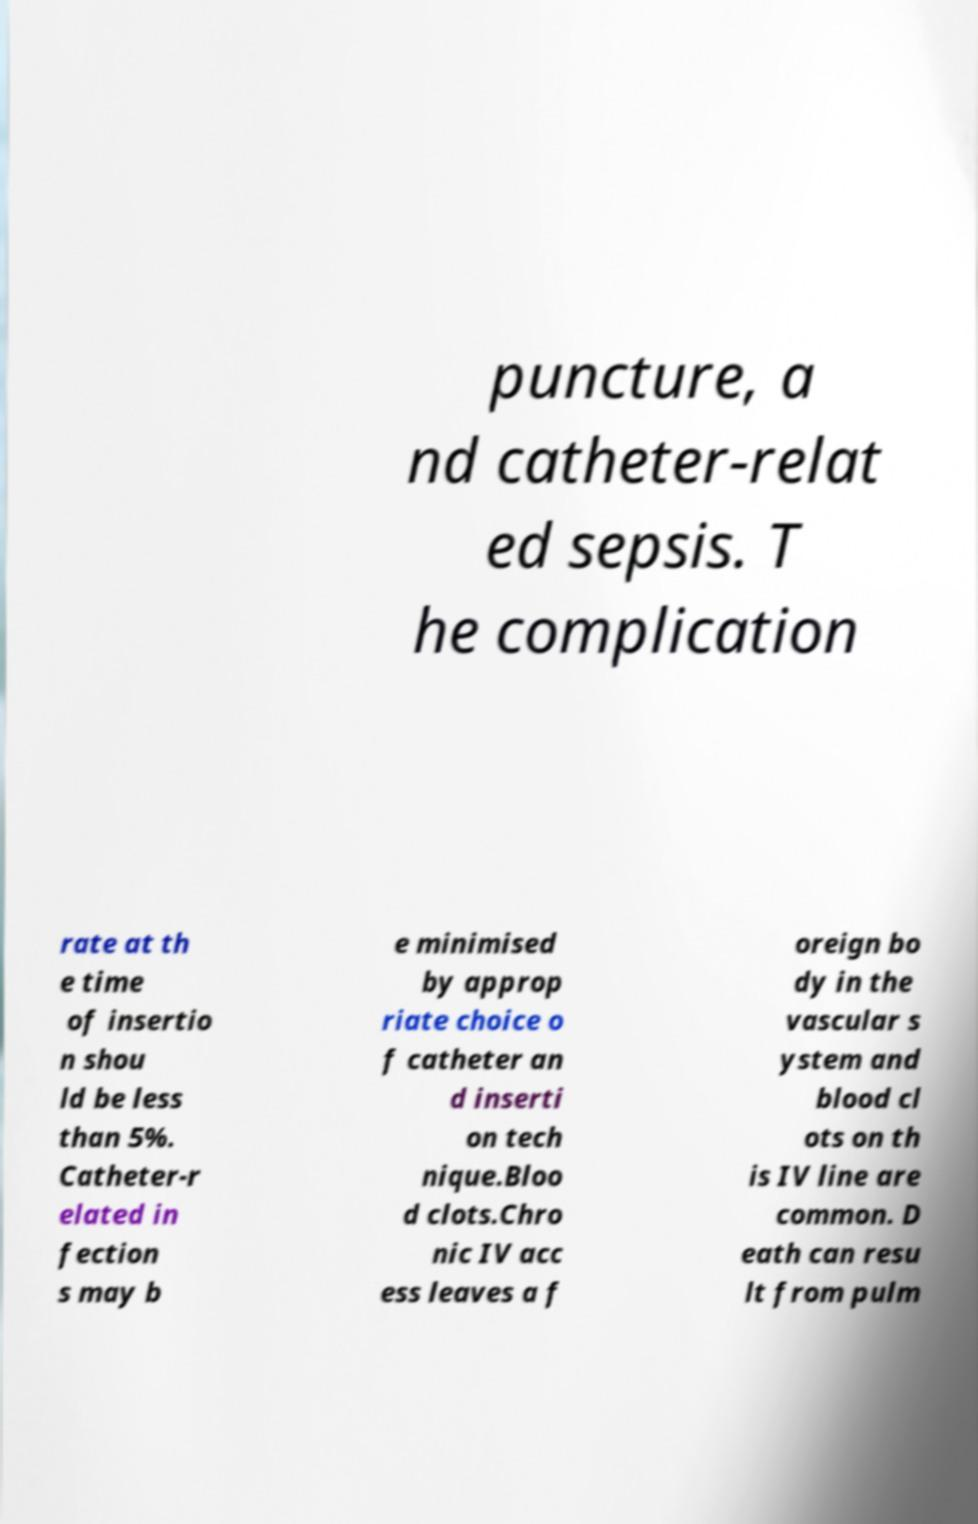What messages or text are displayed in this image? I need them in a readable, typed format. puncture, a nd catheter-relat ed sepsis. T he complication rate at th e time of insertio n shou ld be less than 5%. Catheter-r elated in fection s may b e minimised by approp riate choice o f catheter an d inserti on tech nique.Bloo d clots.Chro nic IV acc ess leaves a f oreign bo dy in the vascular s ystem and blood cl ots on th is IV line are common. D eath can resu lt from pulm 